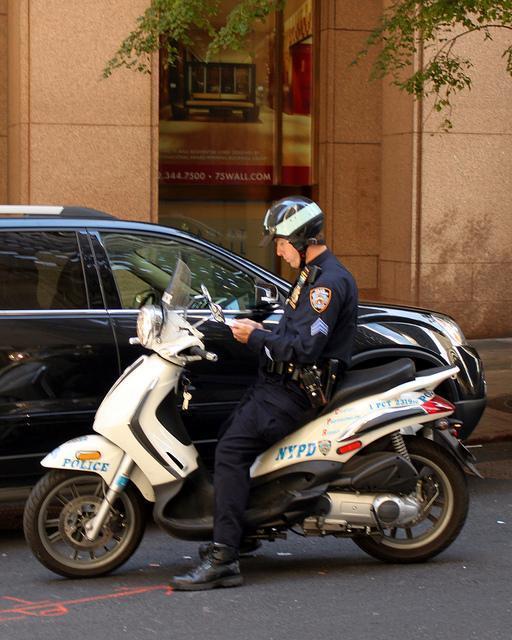How many ovens in this image have a window on their door?
Give a very brief answer. 0. 